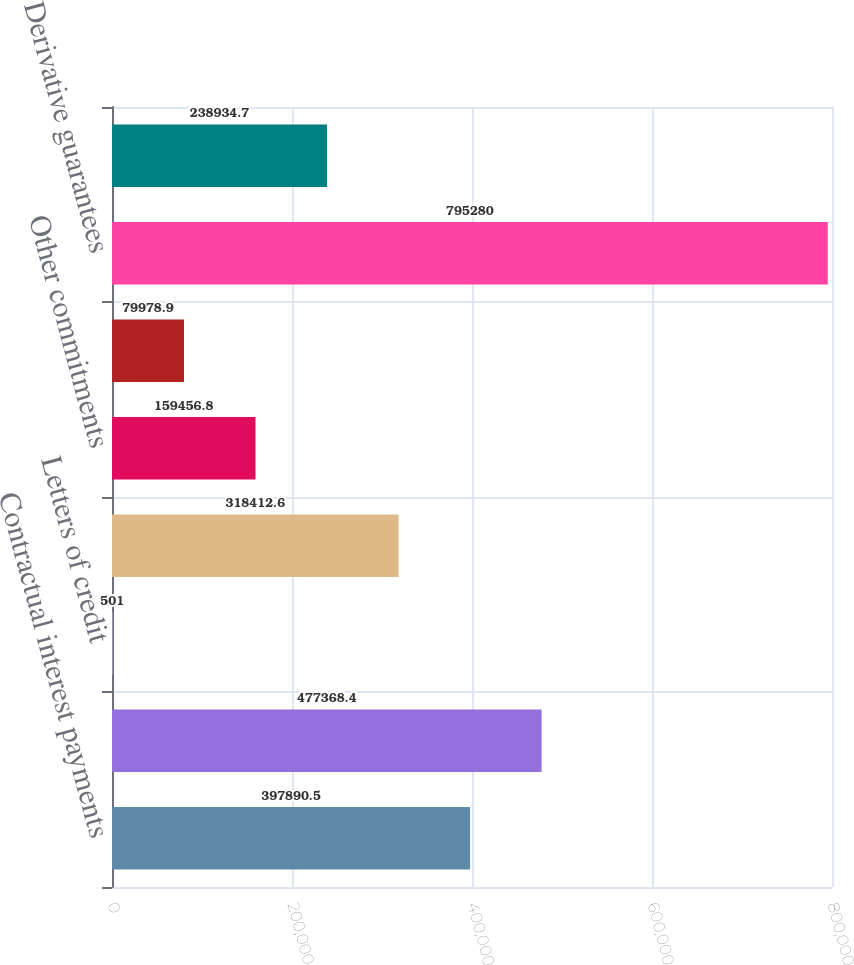Convert chart. <chart><loc_0><loc_0><loc_500><loc_500><bar_chart><fcel>Contractual interest payments<fcel>Commitments to extend credit<fcel>Letters of credit<fcel>Investment commitments 4<fcel>Other commitments<fcel>Minimum rental payments<fcel>Derivative guarantees<fcel>Other financial guarantees<nl><fcel>397890<fcel>477368<fcel>501<fcel>318413<fcel>159457<fcel>79978.9<fcel>795280<fcel>238935<nl></chart> 